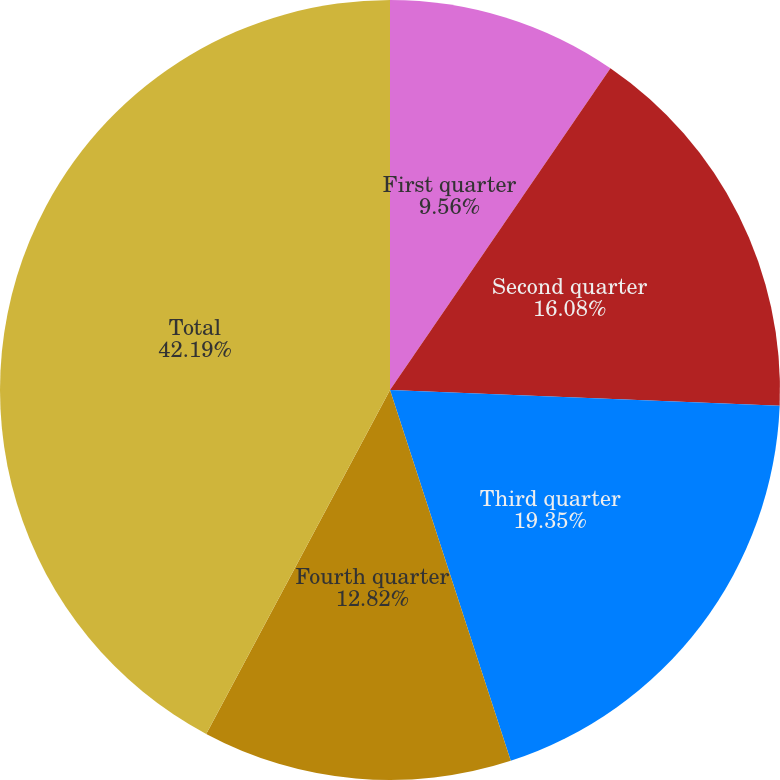Convert chart to OTSL. <chart><loc_0><loc_0><loc_500><loc_500><pie_chart><fcel>First quarter<fcel>Second quarter<fcel>Third quarter<fcel>Fourth quarter<fcel>Total<nl><fcel>9.56%<fcel>16.08%<fcel>19.35%<fcel>12.82%<fcel>42.19%<nl></chart> 